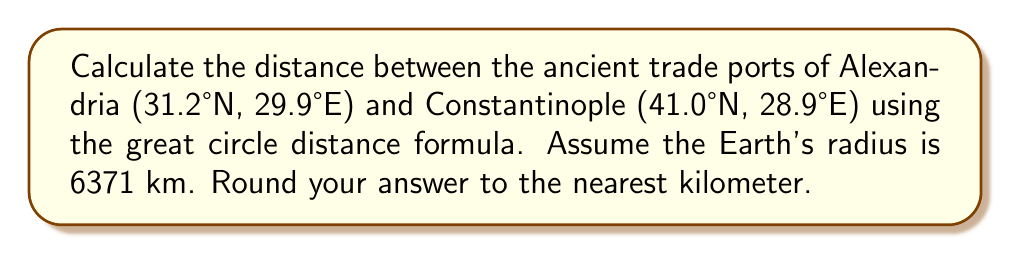What is the answer to this math problem? To calculate the distance between two points on Earth using their latitude and longitude coordinates, we use the great circle distance formula:

$$d = r \cdot \arccos(\sin(\phi_1) \sin(\phi_2) + \cos(\phi_1) \cos(\phi_2) \cos(\Delta \lambda))$$

Where:
- $d$ is the distance
- $r$ is the Earth's radius (6371 km)
- $\phi_1$ and $\phi_2$ are the latitudes of the two points in radians
- $\Delta \lambda$ is the absolute difference between the longitudes in radians

Step 1: Convert latitudes and longitudes from degrees to radians:
$\phi_1 = 31.2° \cdot \frac{\pi}{180} = 0.5445$ radians
$\phi_2 = 41.0° \cdot \frac{\pi}{180} = 0.7156$ radians
$\lambda_1 = 29.9° \cdot \frac{\pi}{180} = 0.5218$ radians
$\lambda_2 = 28.9° \cdot \frac{\pi}{180} = 0.5044$ radians

Step 2: Calculate $\Delta \lambda$:
$\Delta \lambda = |\lambda_1 - \lambda_2| = |0.5218 - 0.5044| = 0.0174$ radians

Step 3: Apply the great circle distance formula:
$$\begin{align*}
d &= 6371 \cdot \arccos(\sin(0.5445) \sin(0.7156) + \cos(0.5445) \cos(0.7156) \cos(0.0174)) \\
&= 6371 \cdot \arccos(0.4651 + 0.5306) \\
&= 6371 \cdot \arccos(0.9957) \\
&= 6371 \cdot 0.0925 \\
&= 589.3215 \text{ km}
\end{align*}$$

Step 4: Round to the nearest kilometer:
$589.3215 \text{ km} \approx 589 \text{ km}$
Answer: 589 km 